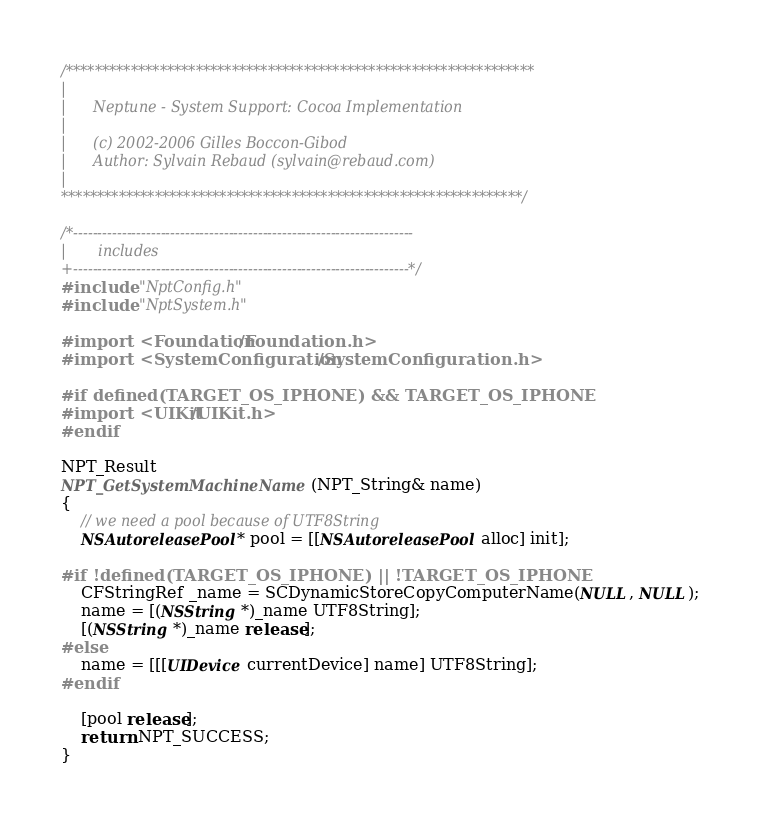Convert code to text. <code><loc_0><loc_0><loc_500><loc_500><_ObjectiveC_>/*****************************************************************
|
|      Neptune - System Support: Cocoa Implementation
|
|      (c) 2002-2006 Gilles Boccon-Gibod
|      Author: Sylvain Rebaud (sylvain@rebaud.com)
|
****************************************************************/

/*----------------------------------------------------------------------
|       includes
+---------------------------------------------------------------------*/
#include "NptConfig.h"
#include "NptSystem.h"

#import <Foundation/Foundation.h>
#import <SystemConfiguration/SystemConfiguration.h>

#if defined(TARGET_OS_IPHONE) && TARGET_OS_IPHONE
#import <UIKit/UIKit.h>
#endif

NPT_Result
NPT_GetSystemMachineName(NPT_String& name)
{
    // we need a pool because of UTF8String
    NSAutoreleasePool* pool = [[NSAutoreleasePool alloc] init];
    
#if !defined(TARGET_OS_IPHONE) || !TARGET_OS_IPHONE
    CFStringRef _name = SCDynamicStoreCopyComputerName(NULL, NULL);
    name = [(NSString *)_name UTF8String];
    [(NSString *)_name release];
#else
    name = [[[UIDevice currentDevice] name] UTF8String];
#endif
    
    [pool release];
    return NPT_SUCCESS;
}
</code> 